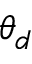Convert formula to latex. <formula><loc_0><loc_0><loc_500><loc_500>\theta _ { d }</formula> 